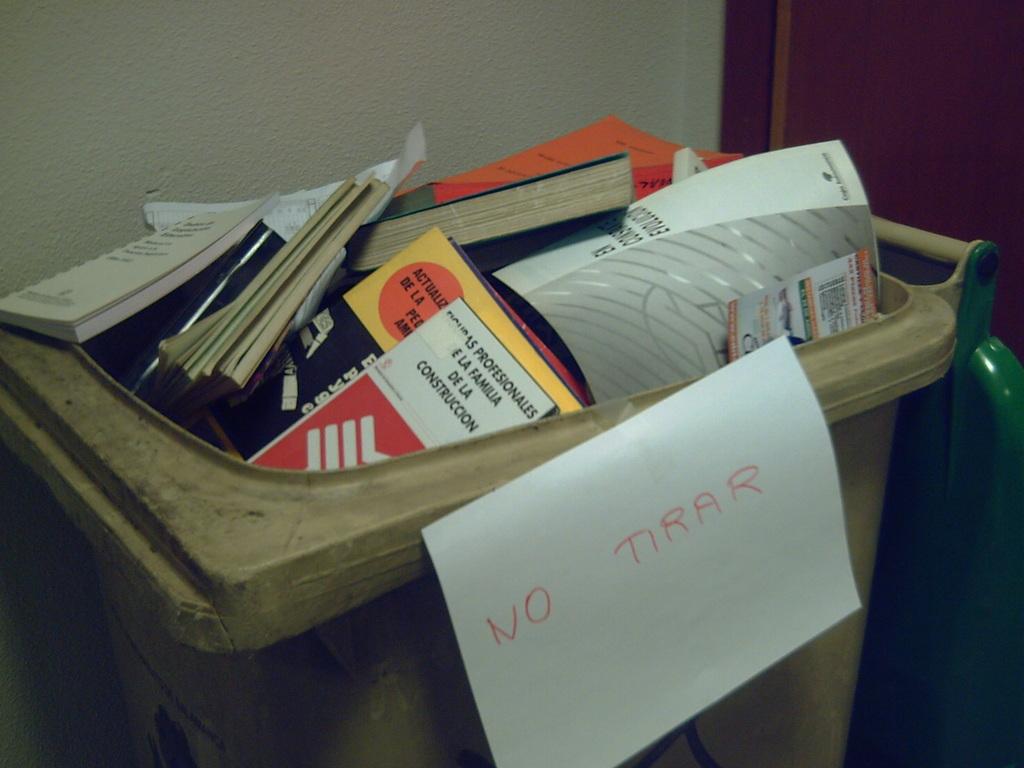What does the note on the can say?
Give a very brief answer. No tirar. 